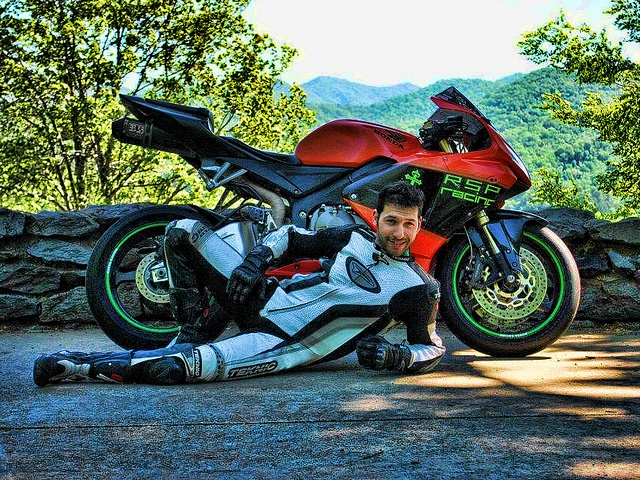Describe the objects in this image and their specific colors. I can see motorcycle in turquoise, black, blue, maroon, and navy tones and people in turquoise, black, lightblue, and blue tones in this image. 